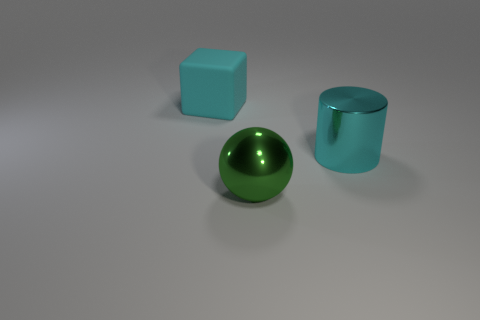Add 3 large things. How many objects exist? 6 Subtract all cylinders. How many objects are left? 2 Add 2 cyan rubber blocks. How many cyan rubber blocks exist? 3 Subtract 0 yellow blocks. How many objects are left? 3 Subtract all cyan shiny objects. Subtract all balls. How many objects are left? 1 Add 3 big cyan blocks. How many big cyan blocks are left? 4 